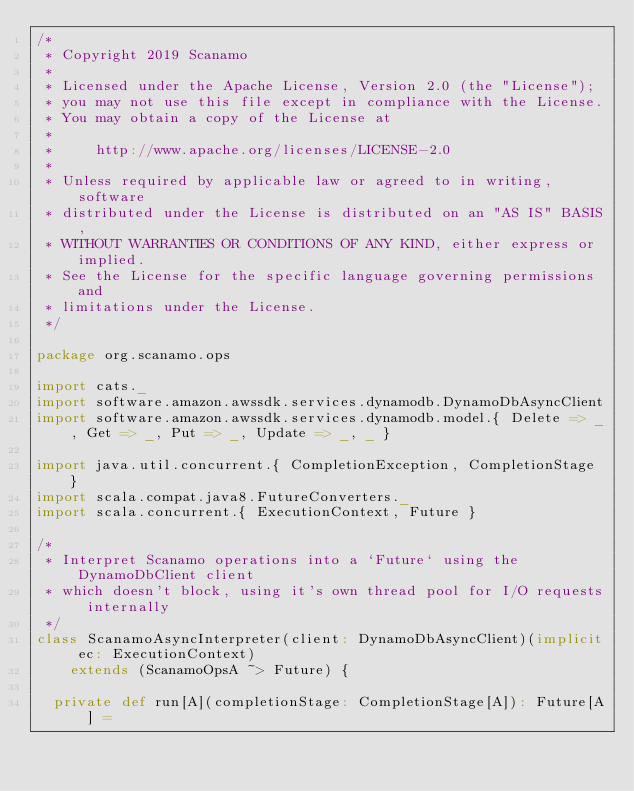<code> <loc_0><loc_0><loc_500><loc_500><_Scala_>/*
 * Copyright 2019 Scanamo
 *
 * Licensed under the Apache License, Version 2.0 (the "License");
 * you may not use this file except in compliance with the License.
 * You may obtain a copy of the License at
 *
 *     http://www.apache.org/licenses/LICENSE-2.0
 *
 * Unless required by applicable law or agreed to in writing, software
 * distributed under the License is distributed on an "AS IS" BASIS,
 * WITHOUT WARRANTIES OR CONDITIONS OF ANY KIND, either express or implied.
 * See the License for the specific language governing permissions and
 * limitations under the License.
 */

package org.scanamo.ops

import cats._
import software.amazon.awssdk.services.dynamodb.DynamoDbAsyncClient
import software.amazon.awssdk.services.dynamodb.model.{ Delete => _, Get => _, Put => _, Update => _, _ }

import java.util.concurrent.{ CompletionException, CompletionStage }
import scala.compat.java8.FutureConverters._
import scala.concurrent.{ ExecutionContext, Future }

/*
 * Interpret Scanamo operations into a `Future` using the DynamoDbClient client
 * which doesn't block, using it's own thread pool for I/O requests internally
 */
class ScanamoAsyncInterpreter(client: DynamoDbAsyncClient)(implicit ec: ExecutionContext)
    extends (ScanamoOpsA ~> Future) {

  private def run[A](completionStage: CompletionStage[A]): Future[A] =</code> 